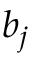<formula> <loc_0><loc_0><loc_500><loc_500>b _ { j }</formula> 